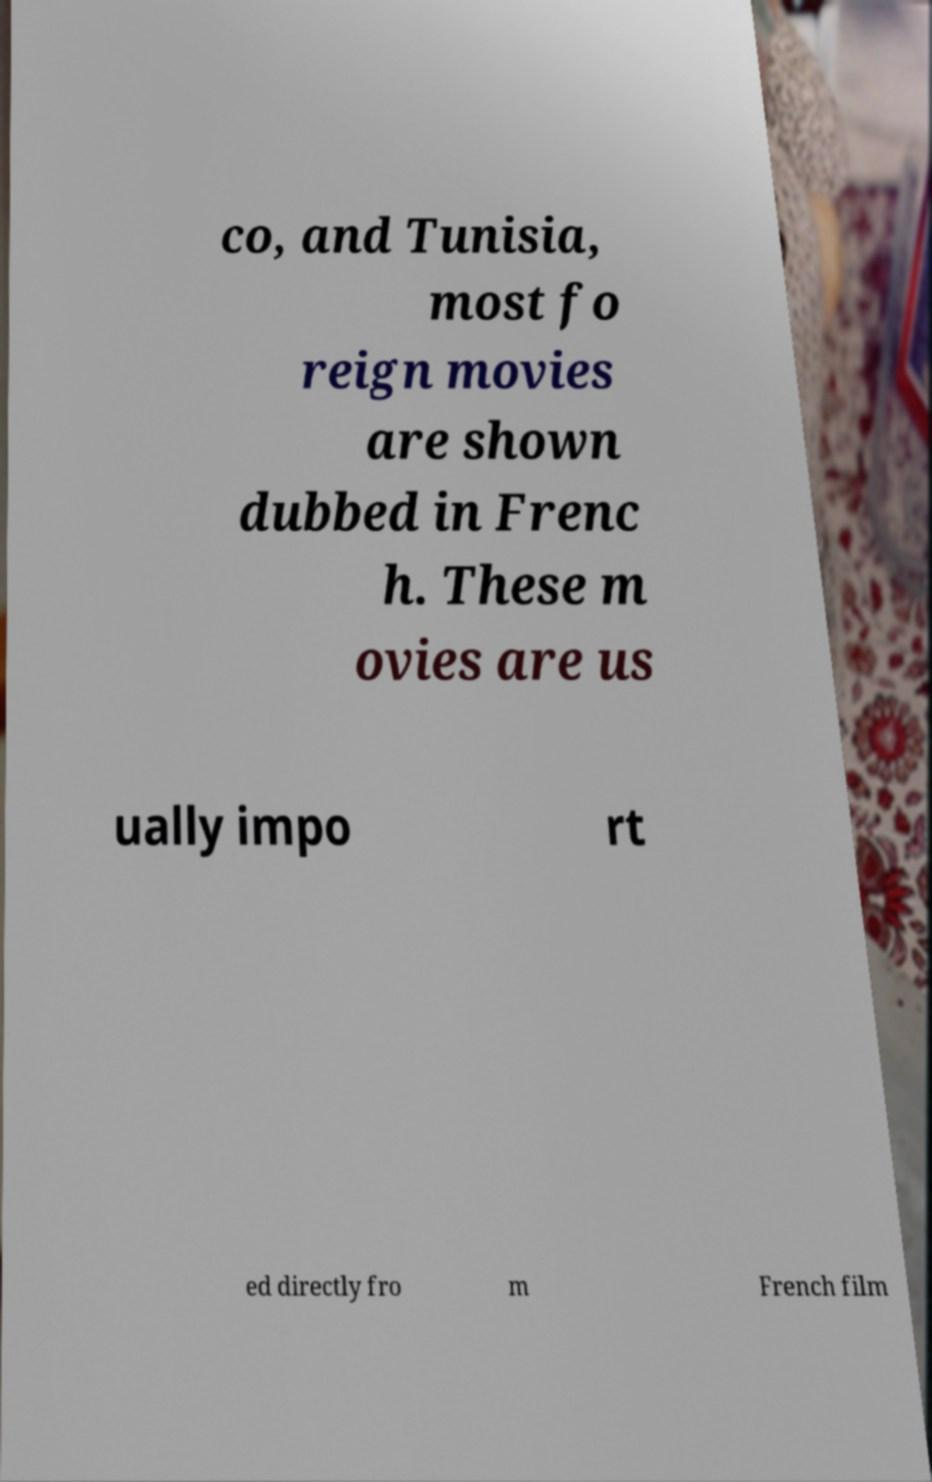Please read and relay the text visible in this image. What does it say? co, and Tunisia, most fo reign movies are shown dubbed in Frenc h. These m ovies are us ually impo rt ed directly fro m French film 